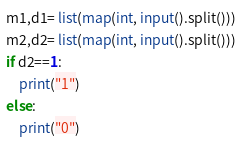<code> <loc_0><loc_0><loc_500><loc_500><_Python_>m1,d1= list(map(int, input().split()))
m2,d2= list(map(int, input().split()))
if d2==1:
    print("1")
else:
    print("0")</code> 